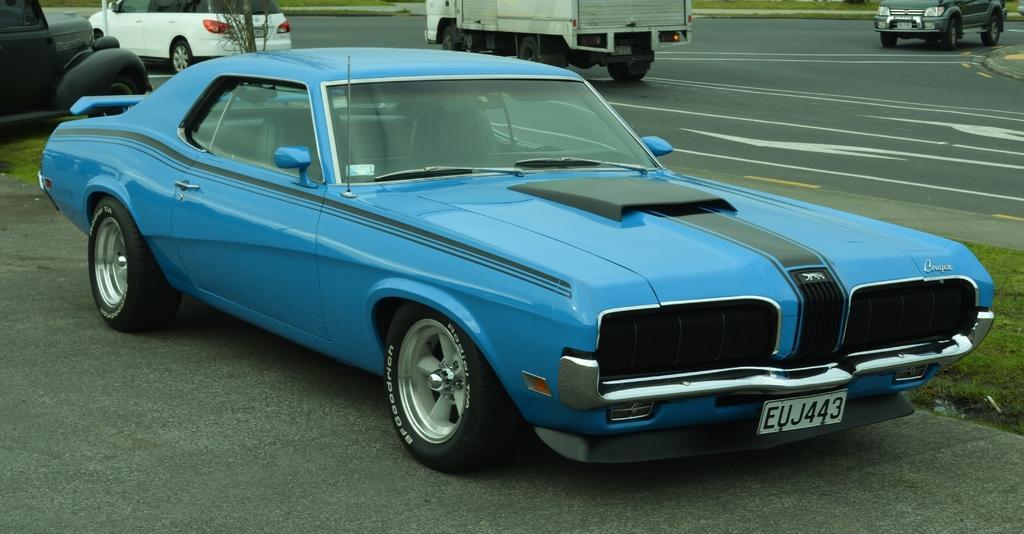In one or two sentences, can you explain what this image depicts? In this image we can see the cars on the ground. We can also see some grass, a plant and some vehicles on the road. 